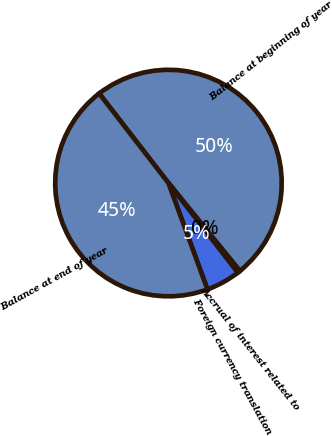<chart> <loc_0><loc_0><loc_500><loc_500><pie_chart><fcel>Balance at beginning of year<fcel>Accrual of interest related to<fcel>Foreign currency translation<fcel>Balance at end of year<nl><fcel>49.63%<fcel>0.37%<fcel>4.89%<fcel>45.11%<nl></chart> 